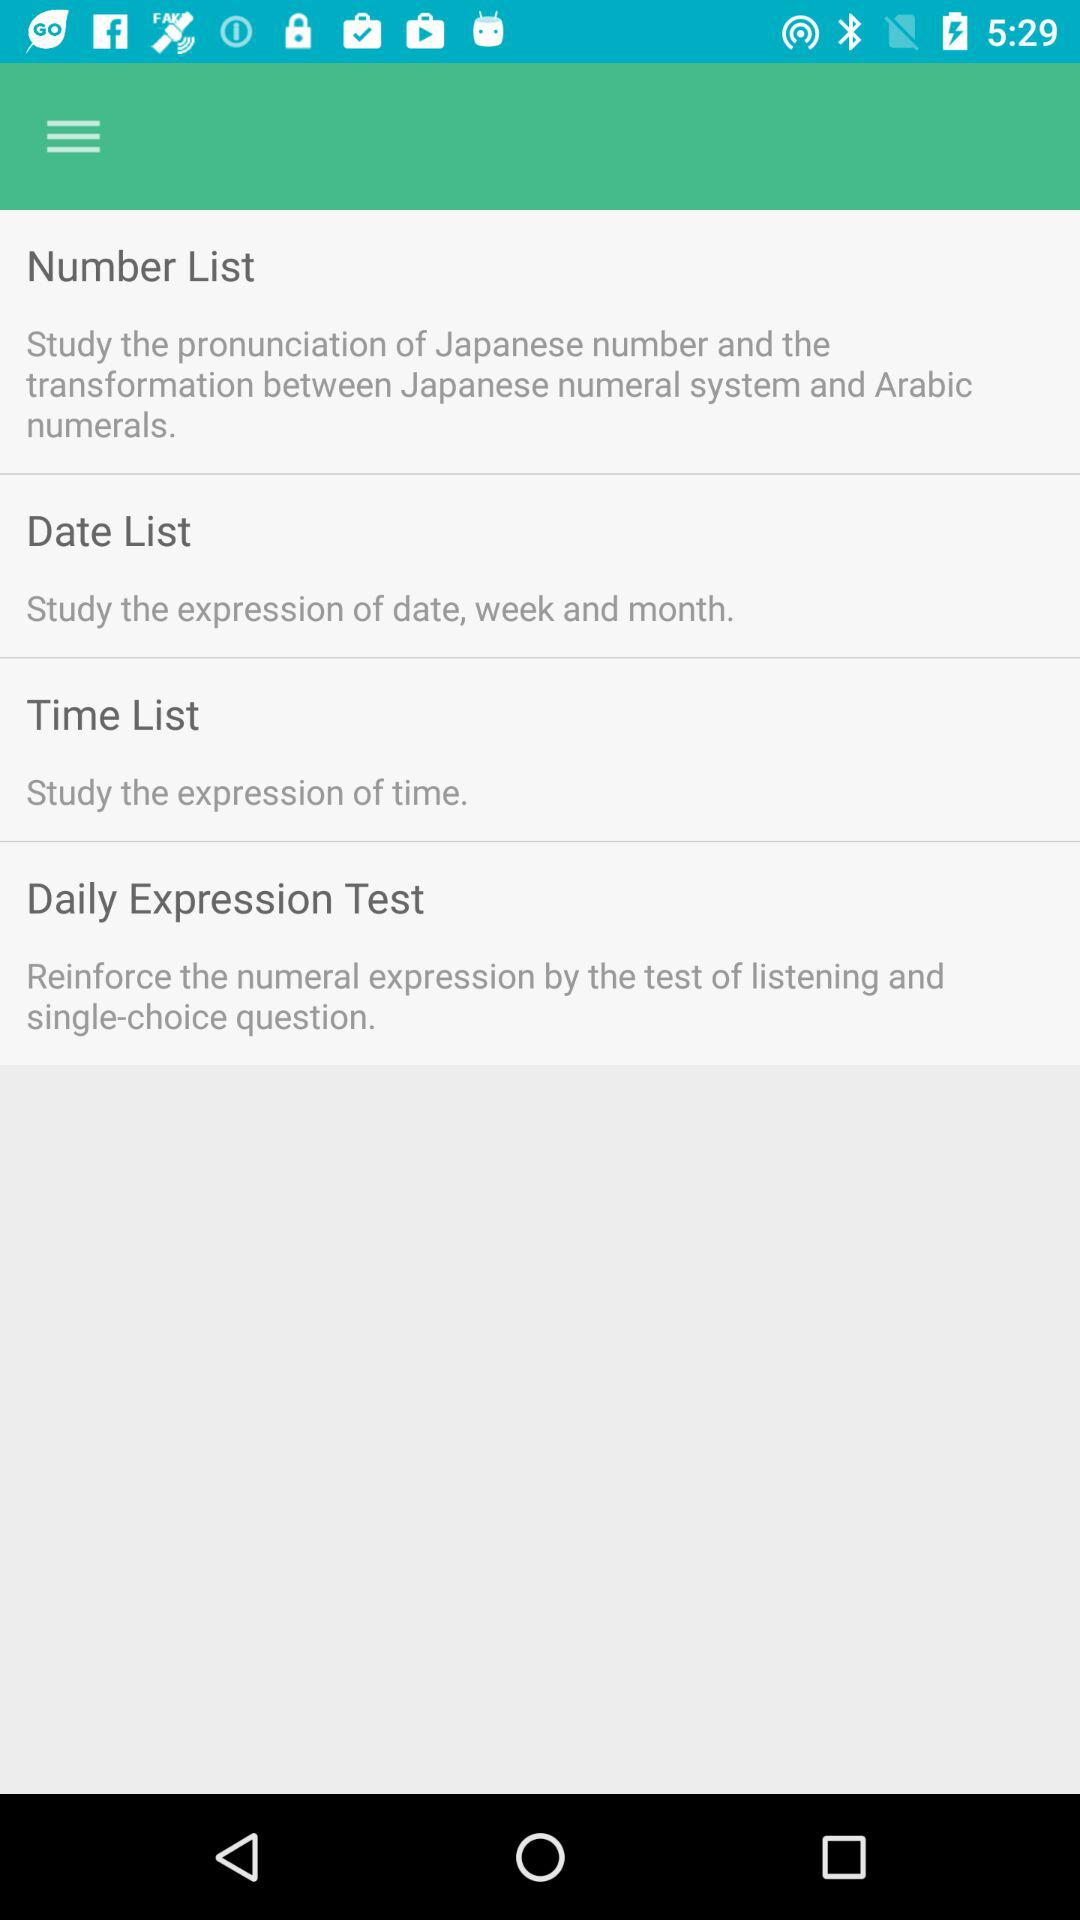What is the description of "Number List"? The description of "Number List" is "Study the pronunciation of Japanese number and the transformation between Japanese numeral system and Arabic numerals". 